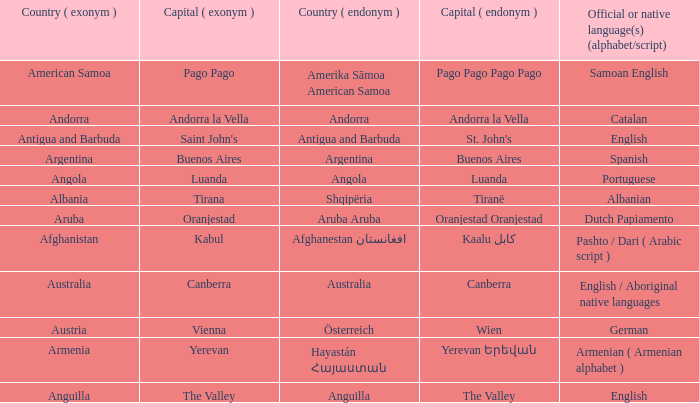What is the local name given to the capital of Anguilla? The Valley. 